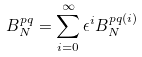<formula> <loc_0><loc_0><loc_500><loc_500>B _ { N } ^ { p q } = \sum _ { i = 0 } ^ { \infty } \epsilon ^ { i } B _ { N } ^ { p q \left ( i \right ) }</formula> 